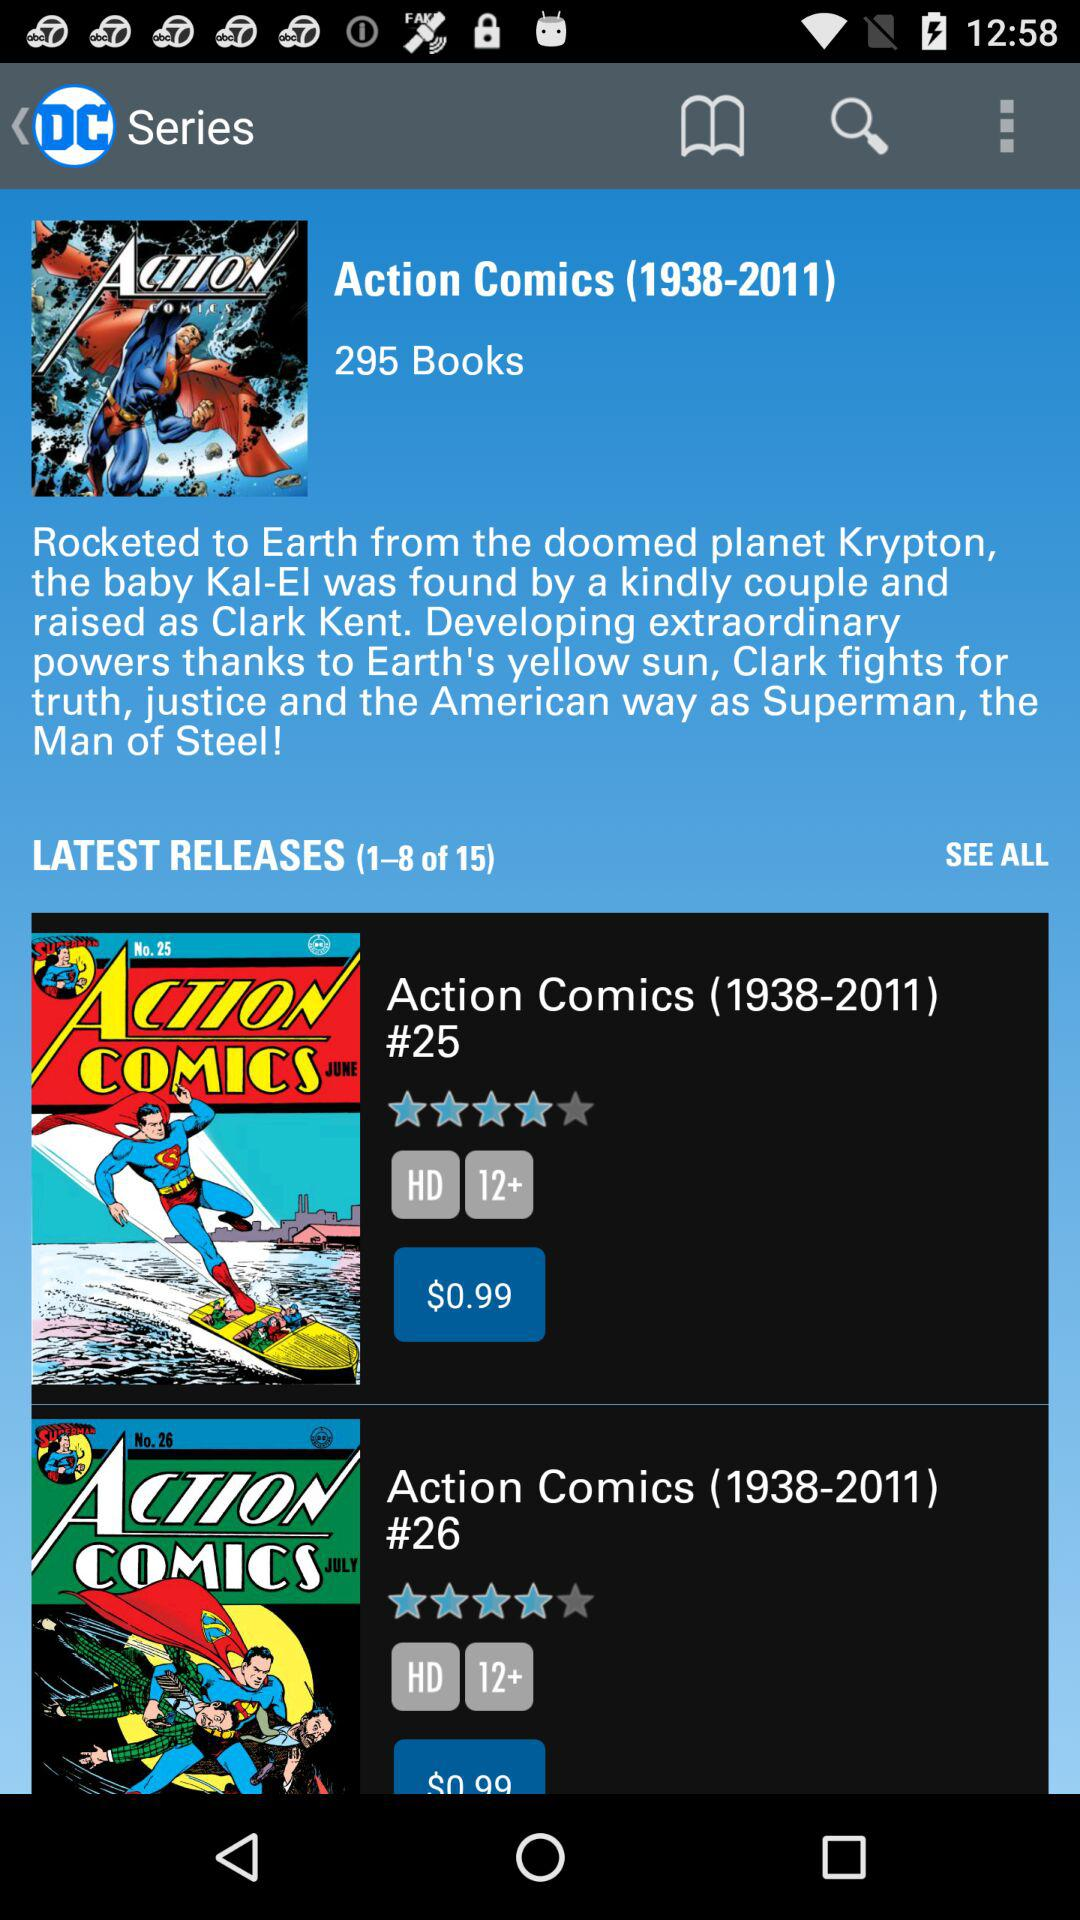How many books are in the series?
Answer the question using a single word or phrase. 295 